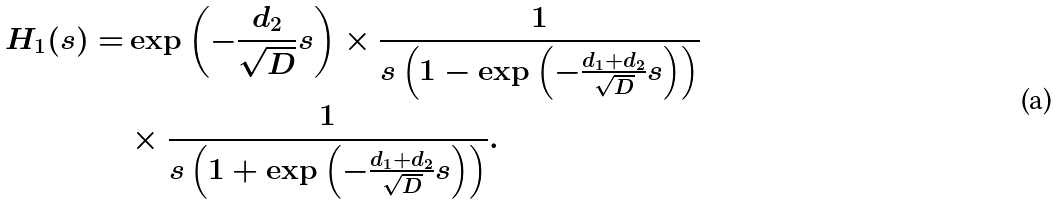<formula> <loc_0><loc_0><loc_500><loc_500>H _ { 1 } ( s ) = & \exp \left ( - \frac { d _ { 2 } } { \sqrt { D } } s \right ) \times \frac { 1 } { s \left ( 1 - \exp \left ( - \frac { d _ { 1 } + d _ { 2 } } { \sqrt { D } } s \right ) \right ) } \\ & \times \frac { 1 } { s \left ( 1 + \exp \left ( - \frac { d _ { 1 } + d _ { 2 } } { \sqrt { D } } s \right ) \right ) } .</formula> 